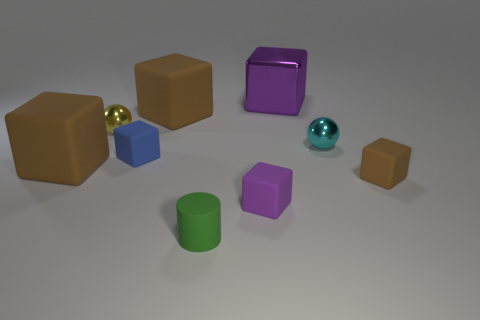What is the shape of the large brown object that is in front of the tiny metal object right of the big brown thing that is right of the blue rubber object?
Your answer should be compact. Cube. What material is the small sphere that is to the right of the cylinder?
Offer a terse response. Metal. The matte cylinder that is the same size as the purple matte thing is what color?
Keep it short and to the point. Green. What number of other objects are there of the same shape as the yellow object?
Offer a very short reply. 1. Is the cylinder the same size as the purple rubber thing?
Keep it short and to the point. Yes. Is the number of large brown matte blocks that are behind the small yellow metallic object greater than the number of green rubber objects in front of the blue object?
Keep it short and to the point. No. How many other objects are there of the same size as the cyan shiny sphere?
Your answer should be very brief. 5. There is a rubber block that is in front of the tiny brown object; does it have the same color as the big metallic cube?
Your answer should be very brief. Yes. Are there more big things in front of the tiny cyan shiny ball than large brown metal spheres?
Provide a succinct answer. Yes. Is there any other thing that has the same color as the large shiny thing?
Your answer should be very brief. Yes. 